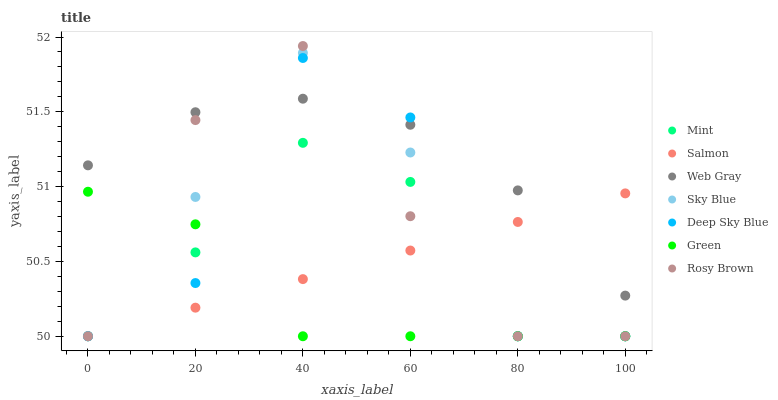Does Green have the minimum area under the curve?
Answer yes or no. Yes. Does Web Gray have the maximum area under the curve?
Answer yes or no. Yes. Does Rosy Brown have the minimum area under the curve?
Answer yes or no. No. Does Rosy Brown have the maximum area under the curve?
Answer yes or no. No. Is Salmon the smoothest?
Answer yes or no. Yes. Is Deep Sky Blue the roughest?
Answer yes or no. Yes. Is Rosy Brown the smoothest?
Answer yes or no. No. Is Rosy Brown the roughest?
Answer yes or no. No. Does Rosy Brown have the lowest value?
Answer yes or no. Yes. Does Rosy Brown have the highest value?
Answer yes or no. Yes. Does Salmon have the highest value?
Answer yes or no. No. Is Mint less than Web Gray?
Answer yes or no. Yes. Is Web Gray greater than Green?
Answer yes or no. Yes. Does Web Gray intersect Sky Blue?
Answer yes or no. Yes. Is Web Gray less than Sky Blue?
Answer yes or no. No. Is Web Gray greater than Sky Blue?
Answer yes or no. No. Does Mint intersect Web Gray?
Answer yes or no. No. 